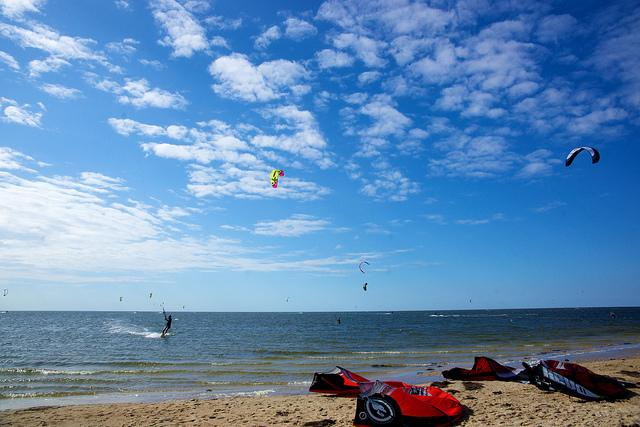What is in the sky? Please explain your reasoning. kite. There are pieces of material guided by ropes 